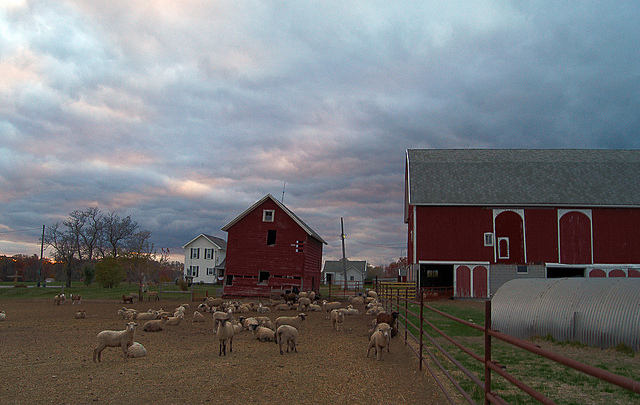<image>Why is there orange color in the clouds? I am not sure why there is orange color in the clouds. It could be due to sunset. Why is there orange color in the clouds? The orange color in the clouds is because of the sunset. 